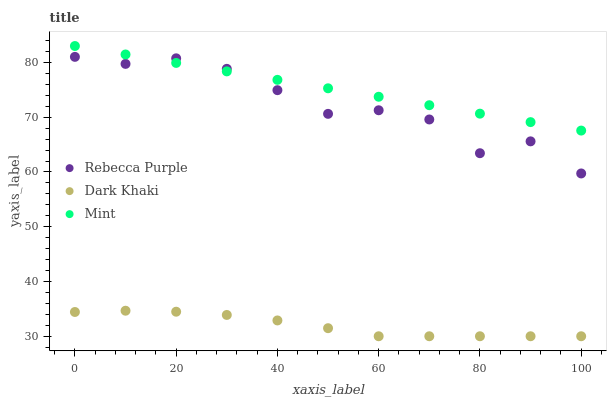Does Dark Khaki have the minimum area under the curve?
Answer yes or no. Yes. Does Mint have the maximum area under the curve?
Answer yes or no. Yes. Does Rebecca Purple have the minimum area under the curve?
Answer yes or no. No. Does Rebecca Purple have the maximum area under the curve?
Answer yes or no. No. Is Mint the smoothest?
Answer yes or no. Yes. Is Rebecca Purple the roughest?
Answer yes or no. Yes. Is Rebecca Purple the smoothest?
Answer yes or no. No. Is Mint the roughest?
Answer yes or no. No. Does Dark Khaki have the lowest value?
Answer yes or no. Yes. Does Rebecca Purple have the lowest value?
Answer yes or no. No. Does Mint have the highest value?
Answer yes or no. Yes. Does Rebecca Purple have the highest value?
Answer yes or no. No. Is Dark Khaki less than Rebecca Purple?
Answer yes or no. Yes. Is Rebecca Purple greater than Dark Khaki?
Answer yes or no. Yes. Does Rebecca Purple intersect Mint?
Answer yes or no. Yes. Is Rebecca Purple less than Mint?
Answer yes or no. No. Is Rebecca Purple greater than Mint?
Answer yes or no. No. Does Dark Khaki intersect Rebecca Purple?
Answer yes or no. No. 